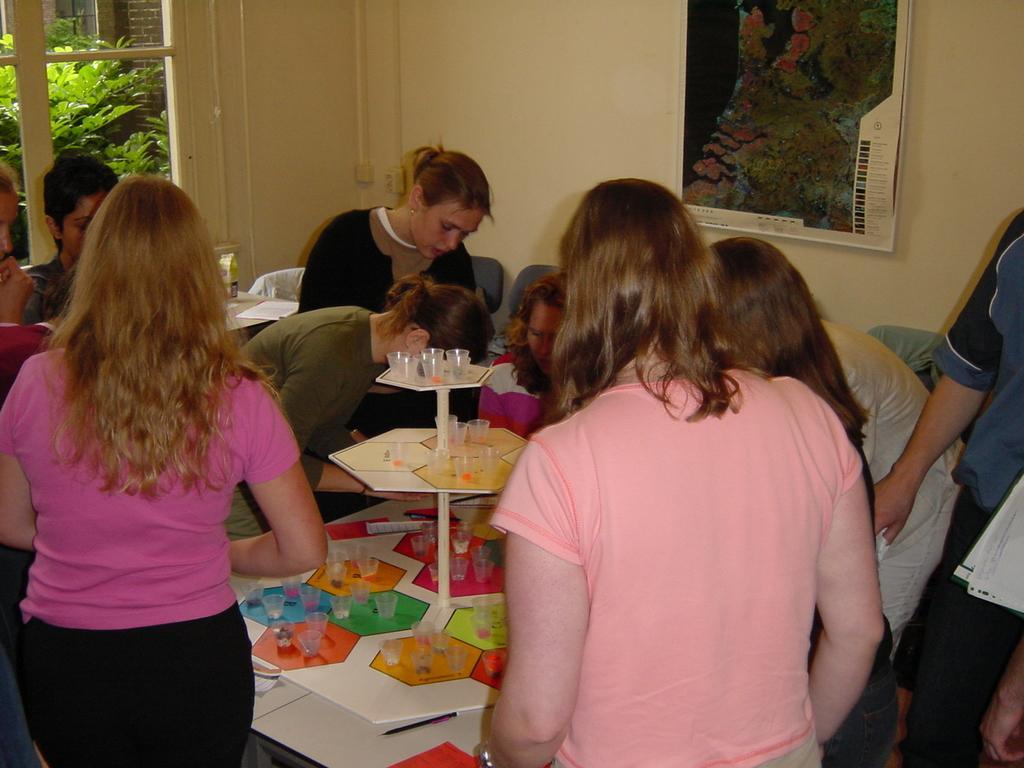Describe this image in one or two sentences. Few persons sitting on the chair and few persons standing. We can see glasses on the table. On the background we can see wall,window,frame. From this glass window we can see tree. 